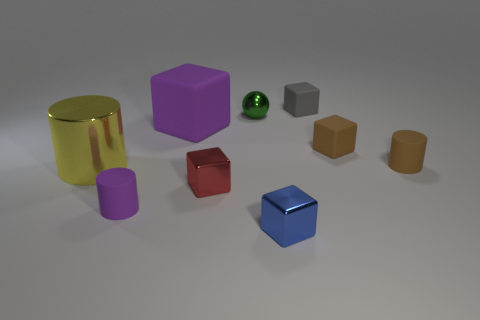Subtract all tiny brown cylinders. How many cylinders are left? 2 Subtract all gray blocks. How many blocks are left? 4 Add 1 tiny purple cylinders. How many objects exist? 10 Subtract all cyan cubes. Subtract all cyan spheres. How many cubes are left? 5 Subtract all spheres. How many objects are left? 8 Add 1 blue things. How many blue things are left? 2 Add 3 small green things. How many small green things exist? 4 Subtract 1 gray blocks. How many objects are left? 8 Subtract all metal balls. Subtract all brown blocks. How many objects are left? 7 